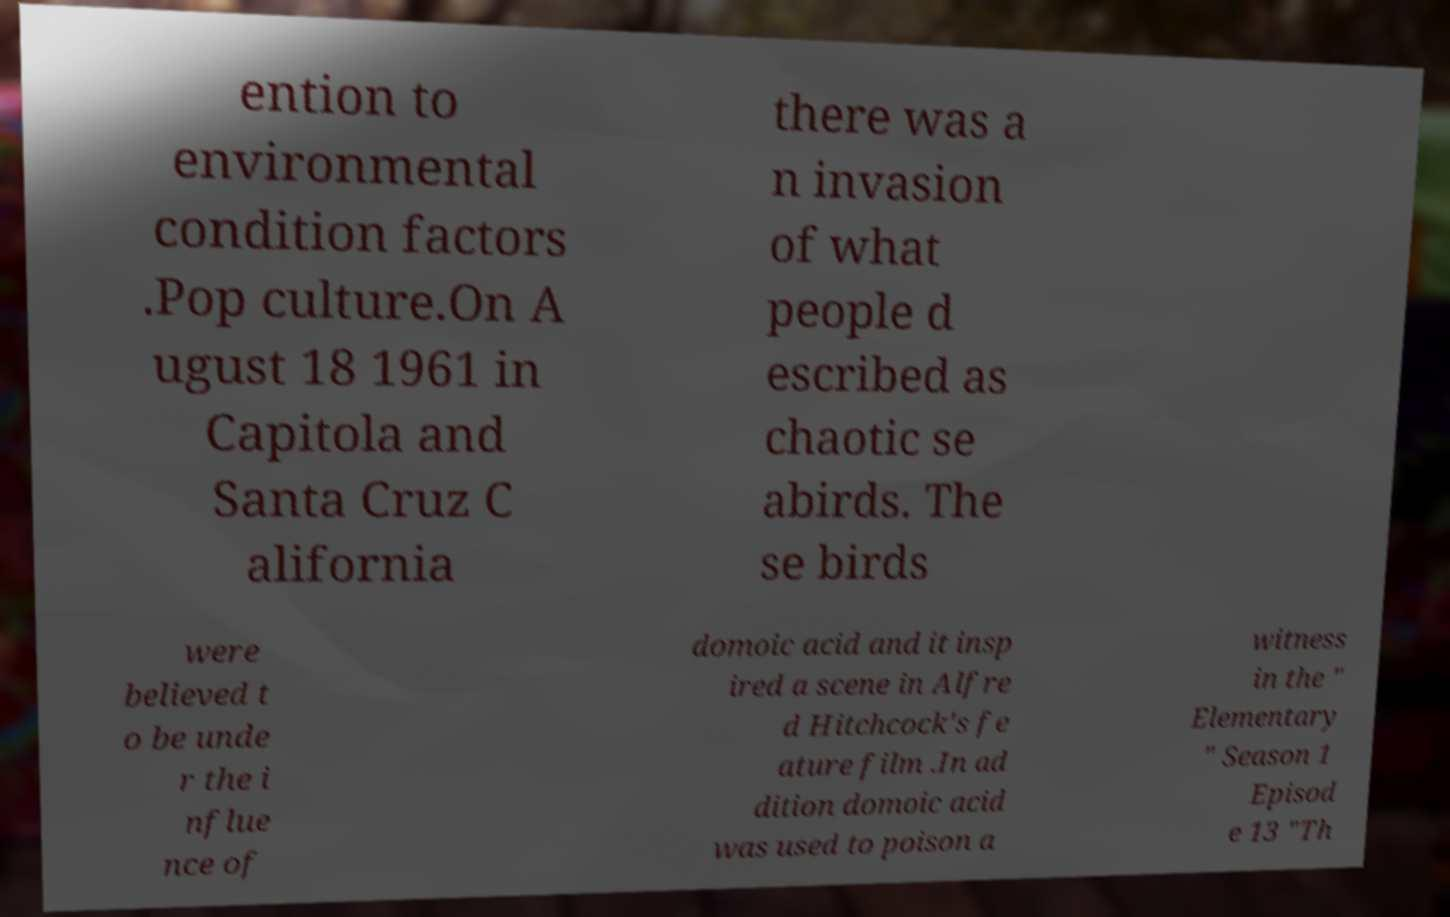What messages or text are displayed in this image? I need them in a readable, typed format. ention to environmental condition factors .Pop culture.On A ugust 18 1961 in Capitola and Santa Cruz C alifornia there was a n invasion of what people d escribed as chaotic se abirds. The se birds were believed t o be unde r the i nflue nce of domoic acid and it insp ired a scene in Alfre d Hitchcock's fe ature film .In ad dition domoic acid was used to poison a witness in the " Elementary " Season 1 Episod e 13 "Th 